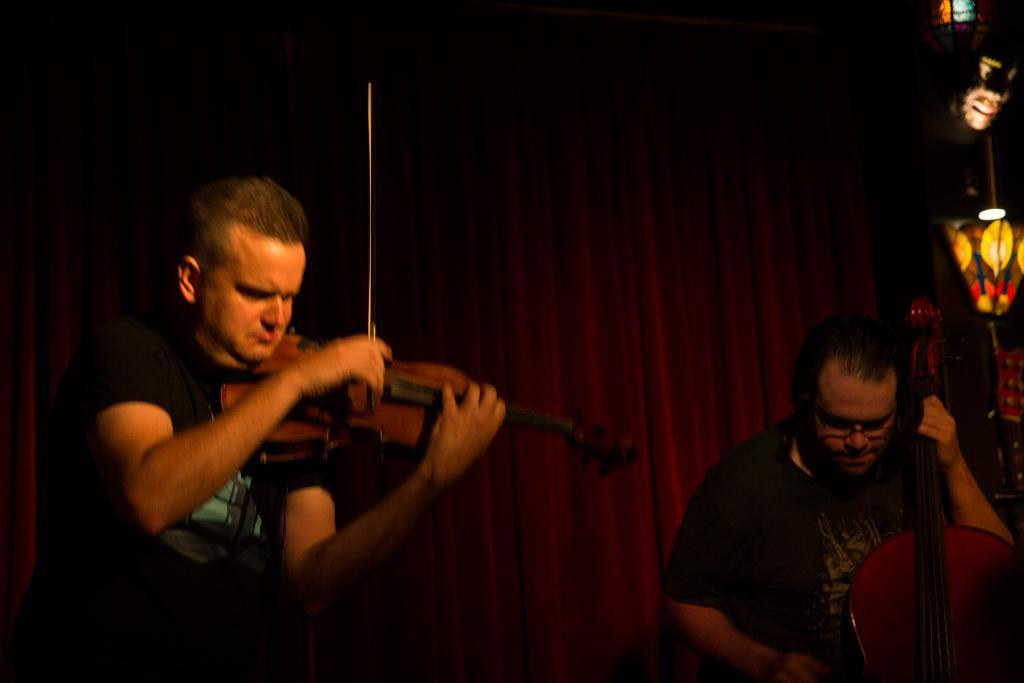How many people are in the image? There are two men in the image. What are the men doing in the image? The men are holding musical instruments. Can you describe any additional features in the image? There are lights visible in the image. How does the sponge affect the sound of the musical instruments in the image? There is no sponge present in the image, so it cannot affect the sound of the musical instruments. 